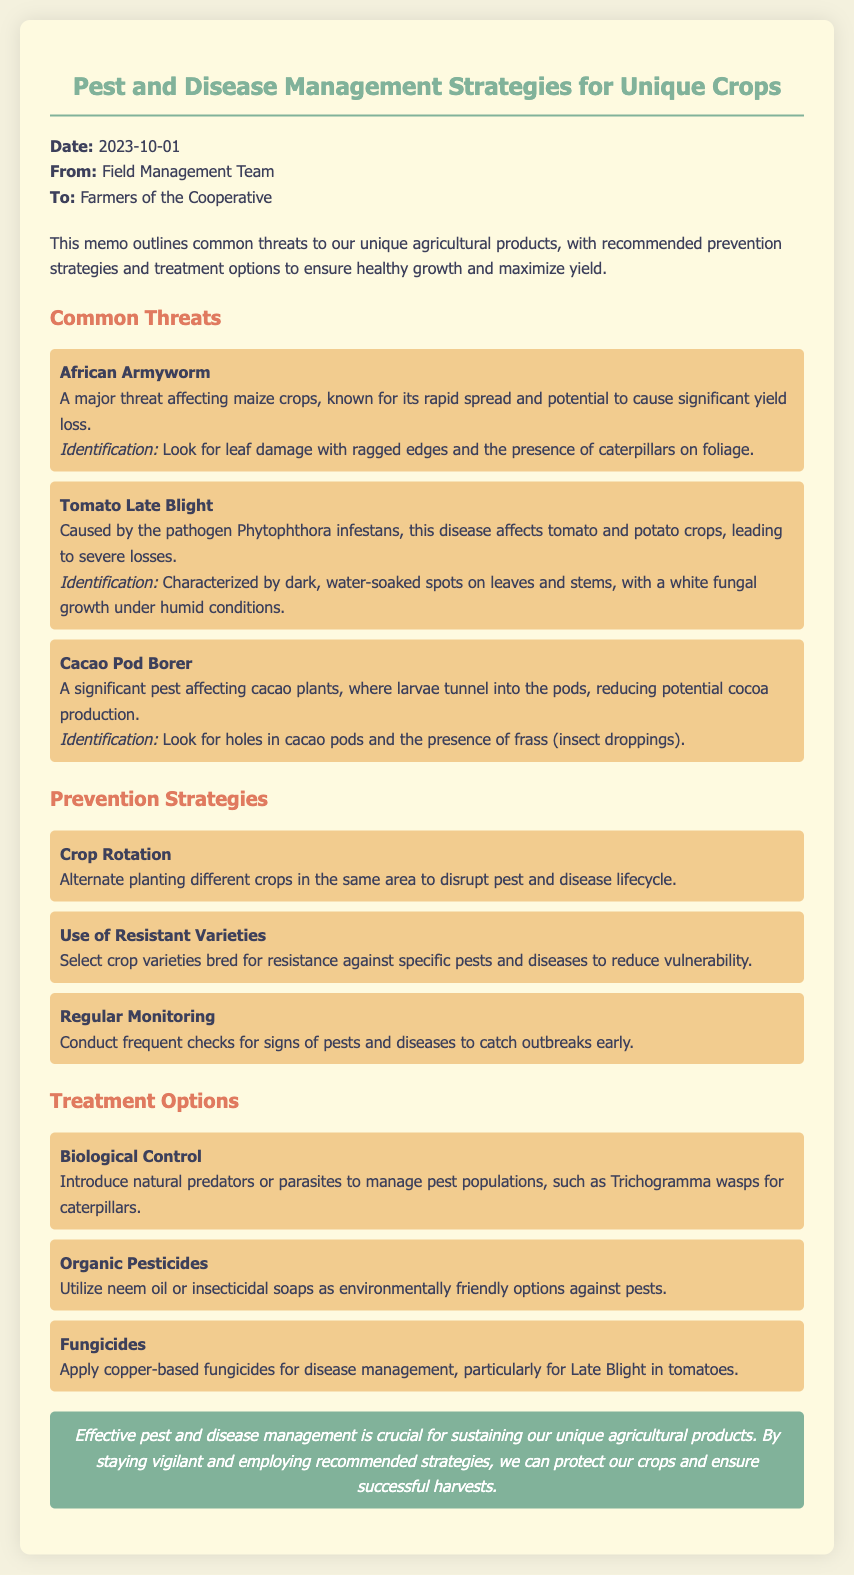What is the date of the memo? The date of the memo is explicitly stated in the document header as 2023-10-01.
Answer: 2023-10-01 Who is the memo addressed to? The memo indicates that it is addressed to the "Farmers of the Cooperative."
Answer: Farmers of the Cooperative What pest is mentioned as a threat to maize crops? The document specifically mentions "African Armyworm" as a major threat to maize crops.
Answer: African Armyworm What is one prevention strategy recommended in the memo? The memo lists "Crop Rotation" as one of the recommended prevention strategies.
Answer: Crop Rotation Which fungicides are suggested for disease management? The document identifies "copper-based fungicides" as suitable for managing diseases like Late Blight.
Answer: copper-based fungicides What pathogen causes Tomato Late Blight? The document specifies that "Phytophthora infestans" is the pathogen responsible for Tomato Late Blight.
Answer: Phytophthora infestans What type of pests can Trichogramma wasps help control? Trichogramma wasps are introduced to manage "caterpillar" pest populations as mentioned in the document.
Answer: caterpillars What is the concluding statement hinting at? The conclusion emphasizes the importance of "effective pest and disease management" for sustainable agriculture.
Answer: effective pest and disease management 